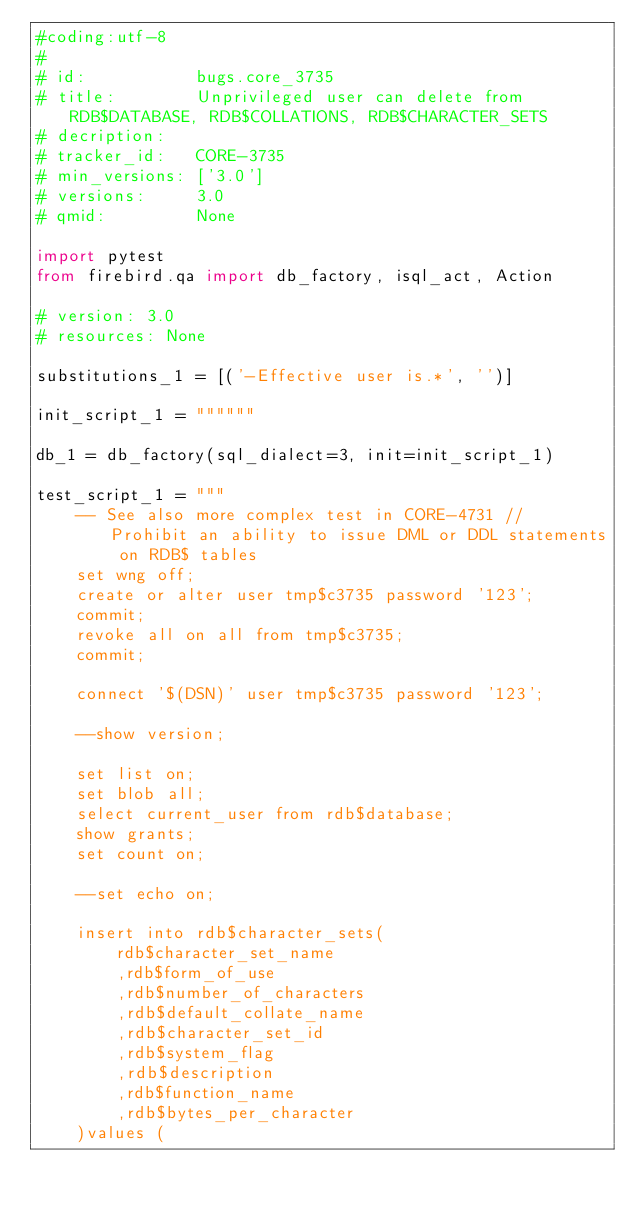<code> <loc_0><loc_0><loc_500><loc_500><_Python_>#coding:utf-8
#
# id:           bugs.core_3735
# title:        Unprivileged user can delete from RDB$DATABASE, RDB$COLLATIONS, RDB$CHARACTER_SETS
# decription:   
# tracker_id:   CORE-3735
# min_versions: ['3.0']
# versions:     3.0
# qmid:         None

import pytest
from firebird.qa import db_factory, isql_act, Action

# version: 3.0
# resources: None

substitutions_1 = [('-Effective user is.*', '')]

init_script_1 = """"""

db_1 = db_factory(sql_dialect=3, init=init_script_1)

test_script_1 = """
    -- See also more complex test in CORE-4731 // Prohibit an ability to issue DML or DDL statements on RDB$ tables
    set wng off;
    create or alter user tmp$c3735 password '123';
    commit;
    revoke all on all from tmp$c3735;
    commit;
    
    connect '$(DSN)' user tmp$c3735 password '123';
    
    --show version;
    
    set list on;
    set blob all;
    select current_user from rdb$database;
    show grants;
    set count on;
    
    --set echo on;
    
    insert into rdb$character_sets(
        rdb$character_set_name
        ,rdb$form_of_use
        ,rdb$number_of_characters
        ,rdb$default_collate_name
        ,rdb$character_set_id
        ,rdb$system_flag
        ,rdb$description
        ,rdb$function_name
        ,rdb$bytes_per_character
    )values (</code> 